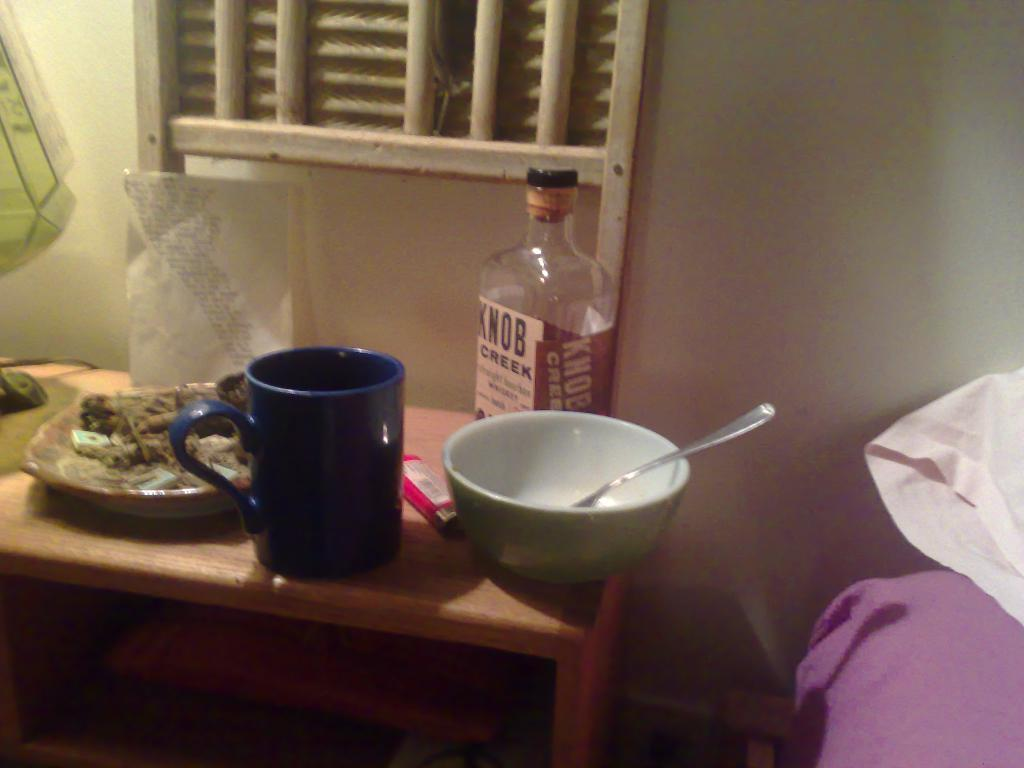<image>
Describe the image concisely. Empty Knob Creek bottle next to a blue cup and a bowl. 